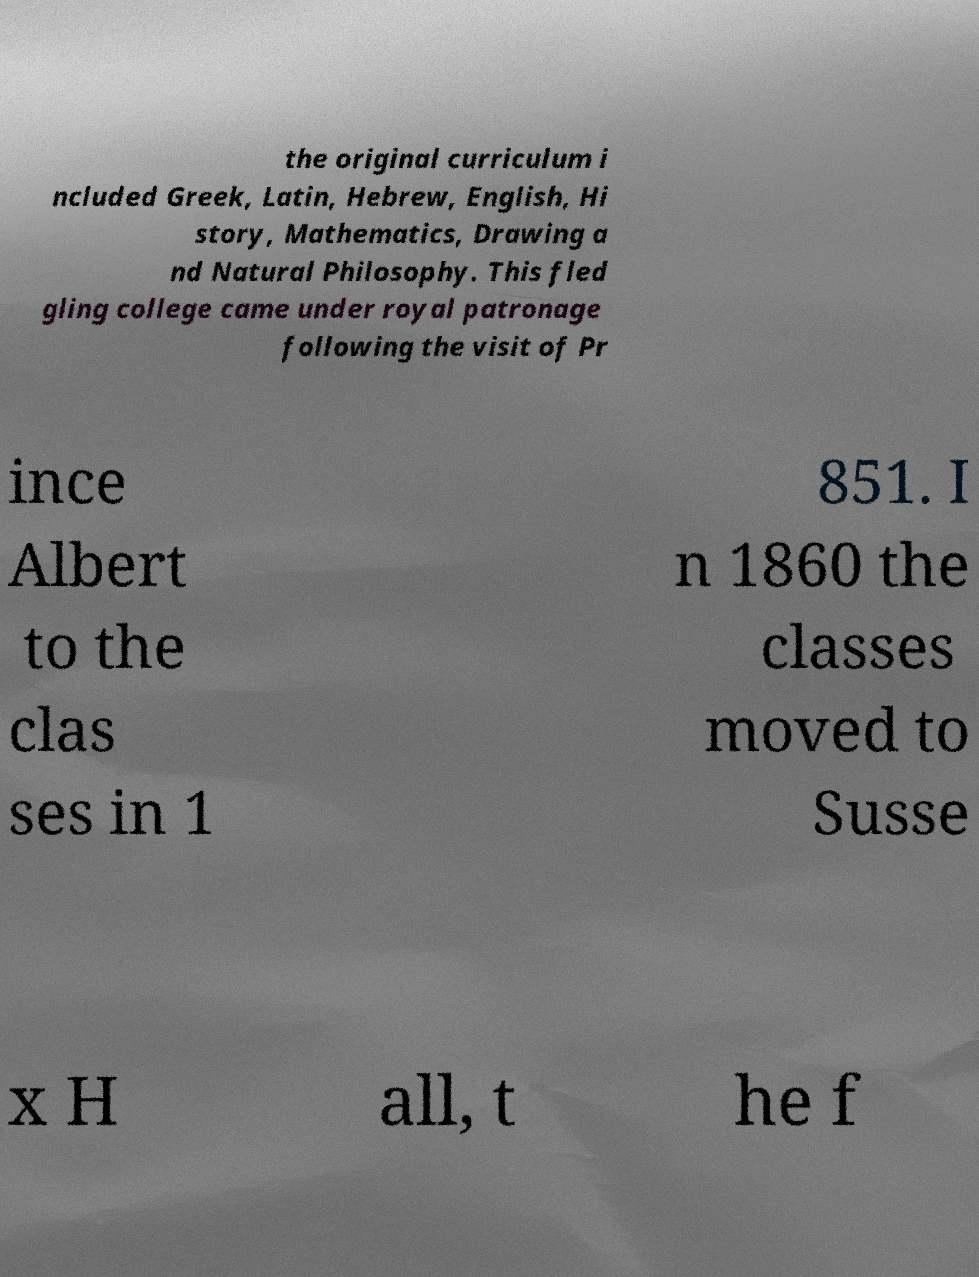Can you read and provide the text displayed in the image?This photo seems to have some interesting text. Can you extract and type it out for me? the original curriculum i ncluded Greek, Latin, Hebrew, English, Hi story, Mathematics, Drawing a nd Natural Philosophy. This fled gling college came under royal patronage following the visit of Pr ince Albert to the clas ses in 1 851. I n 1860 the classes moved to Susse x H all, t he f 